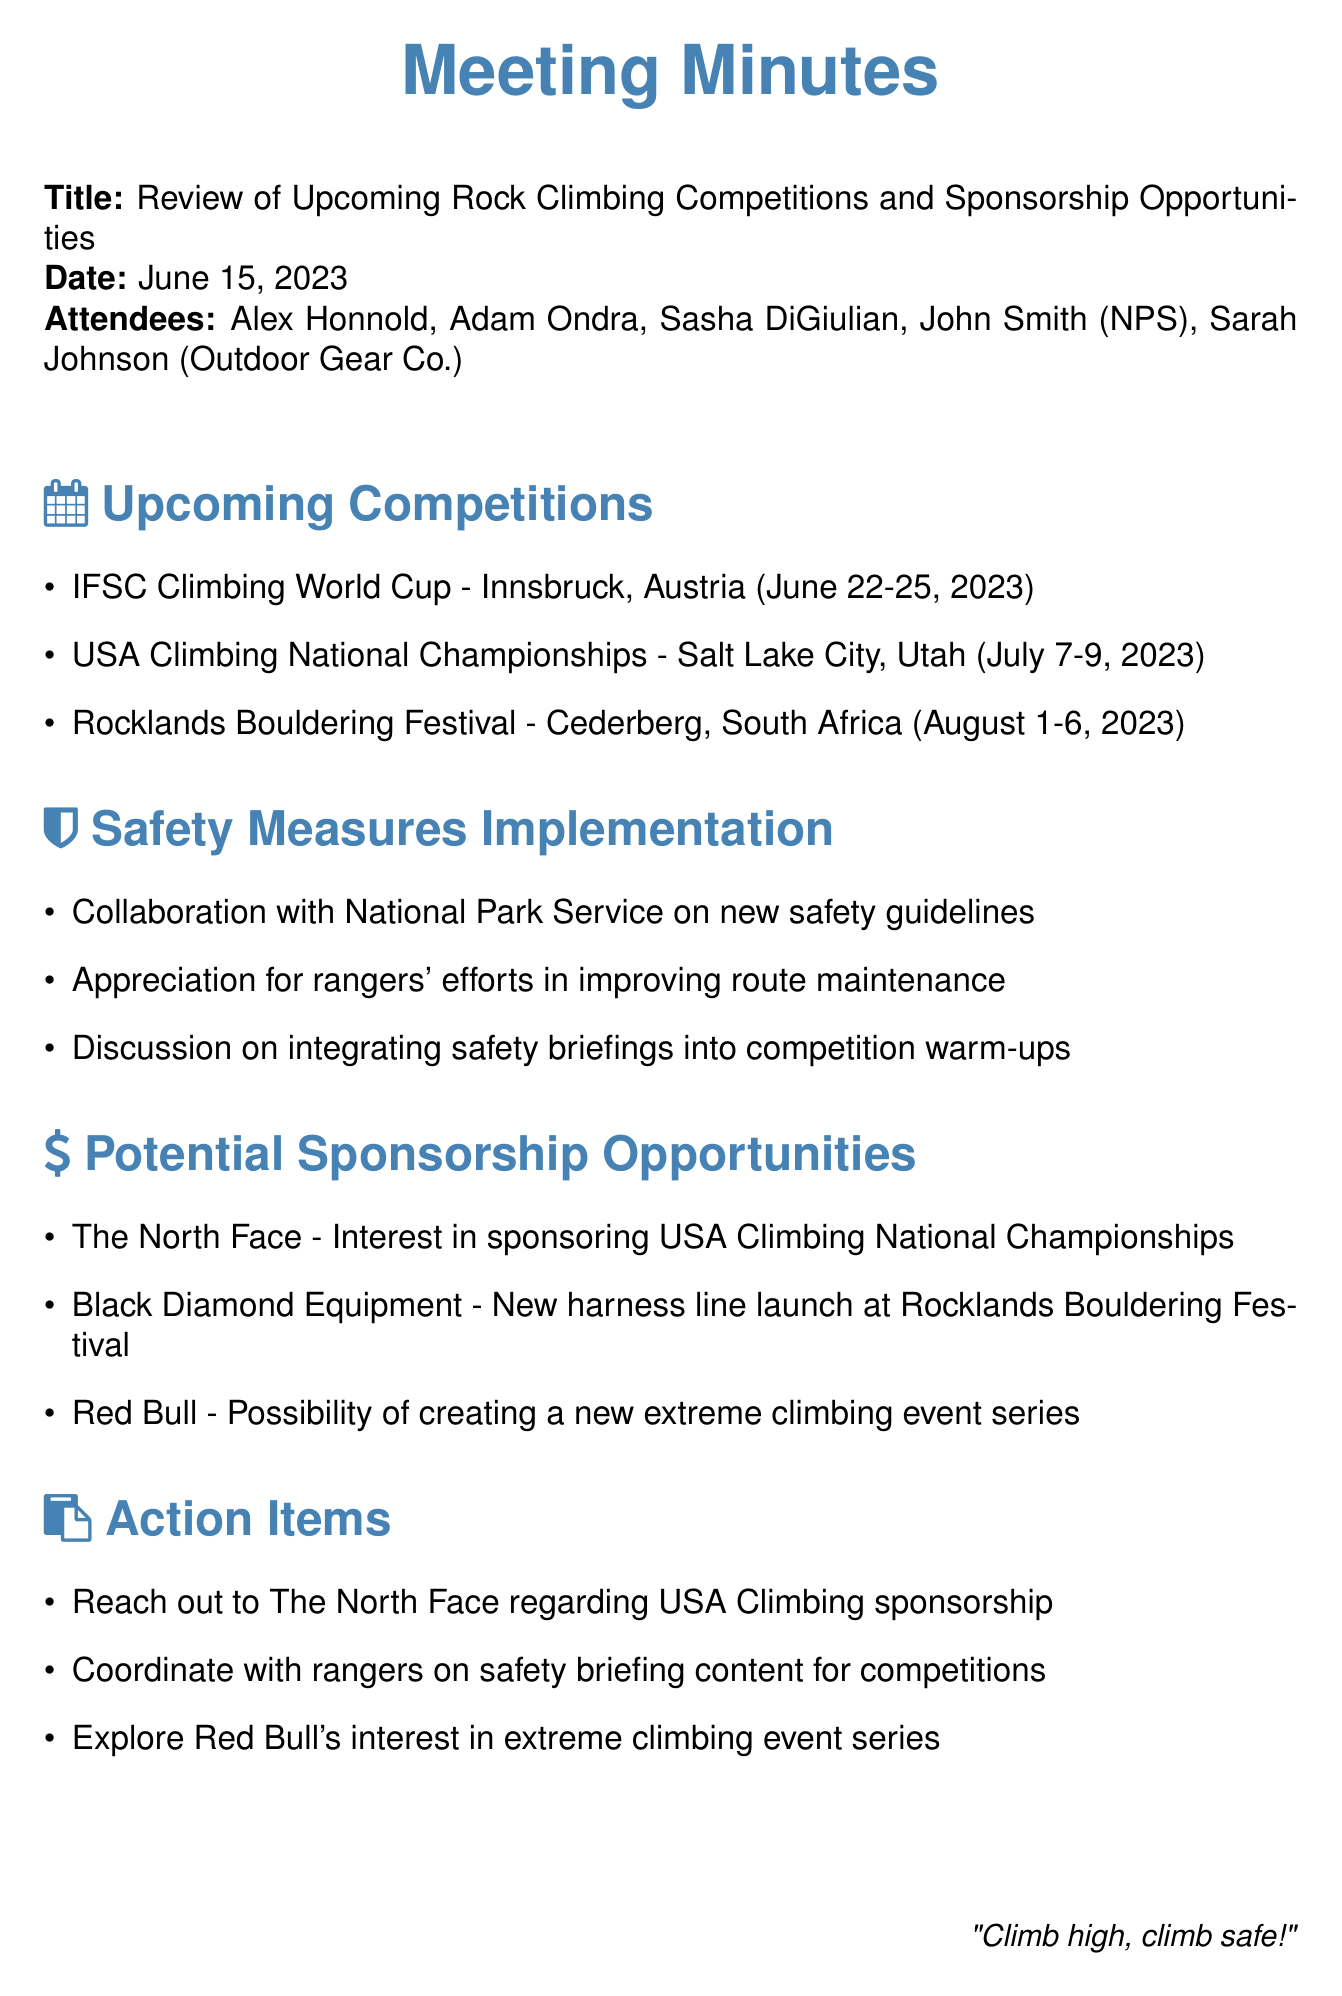what is the title of the meeting? The title of the meeting is stated at the beginning of the document.
Answer: Review of Upcoming Rock Climbing Competitions and Sponsorship Opportunities who represented the National Park Service? The attendance list provides the name of the National Park Service representative.
Answer: John Smith what are the dates of the USA Climbing National Championships? The dates for the USA Climbing National Championships are listed in the upcoming competitions section.
Answer: July 7-9, 2023 which company is interested in sponsoring the USA Climbing National Championships? The sponsorship opportunities section mentions the interested company.
Answer: The North Face how many competitions are mentioned in the document? By counting the items listed under upcoming competitions, we determine the total number.
Answer: Three what safety measures are discussed in relation to competition warm-ups? The document outlines a specific integration of safety protocols during competitions.
Answer: Safety briefings what is the action item regarding The North Face? The action items section provides specific tasks related to The North Face.
Answer: Reach out to The North Face regarding USA Climbing sponsorship who is launching a new harness line at Rocklands Bouldering Festival? The potential sponsorship opportunities list includes the brand launching a new product.
Answer: Black Diamond Equipment what is the proposed extreme climbing event series associated with? The document implies a connection to potential sponsorship opportunities for a new event concept.
Answer: Red Bull 